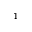<formula> <loc_0><loc_0><loc_500><loc_500>^ { - 1 }</formula> 